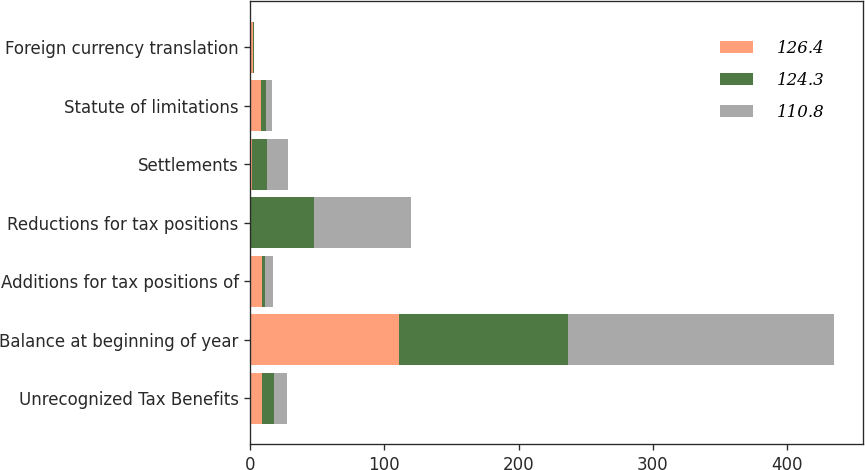<chart> <loc_0><loc_0><loc_500><loc_500><stacked_bar_chart><ecel><fcel>Unrecognized Tax Benefits<fcel>Balance at beginning of year<fcel>Additions for tax positions of<fcel>Reductions for tax positions<fcel>Settlements<fcel>Statute of limitations<fcel>Foreign currency translation<nl><fcel>126.4<fcel>9<fcel>110.8<fcel>9<fcel>0.5<fcel>1.4<fcel>8<fcel>1.7<nl><fcel>124.3<fcel>9<fcel>126.4<fcel>2.3<fcel>46.9<fcel>11<fcel>3.7<fcel>0.8<nl><fcel>110.8<fcel>9<fcel>197.8<fcel>5.7<fcel>72.4<fcel>15.6<fcel>4.8<fcel>0.6<nl></chart> 